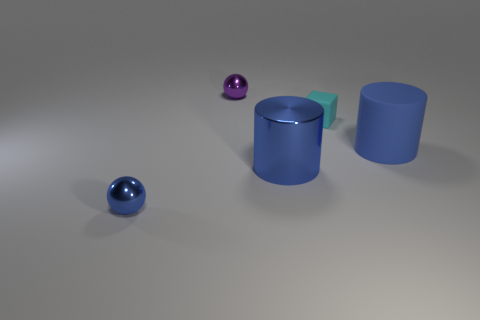Subtract 0 red cubes. How many objects are left? 5 Subtract all spheres. How many objects are left? 3 Subtract 1 spheres. How many spheres are left? 1 Subtract all purple cubes. Subtract all cyan cylinders. How many cubes are left? 1 Subtract all green spheres. How many red cubes are left? 0 Subtract all tiny shiny balls. Subtract all big blue things. How many objects are left? 1 Add 2 cyan cubes. How many cyan cubes are left? 3 Add 4 small gray cylinders. How many small gray cylinders exist? 4 Add 1 tiny yellow things. How many objects exist? 6 Subtract all blue balls. How many balls are left? 1 